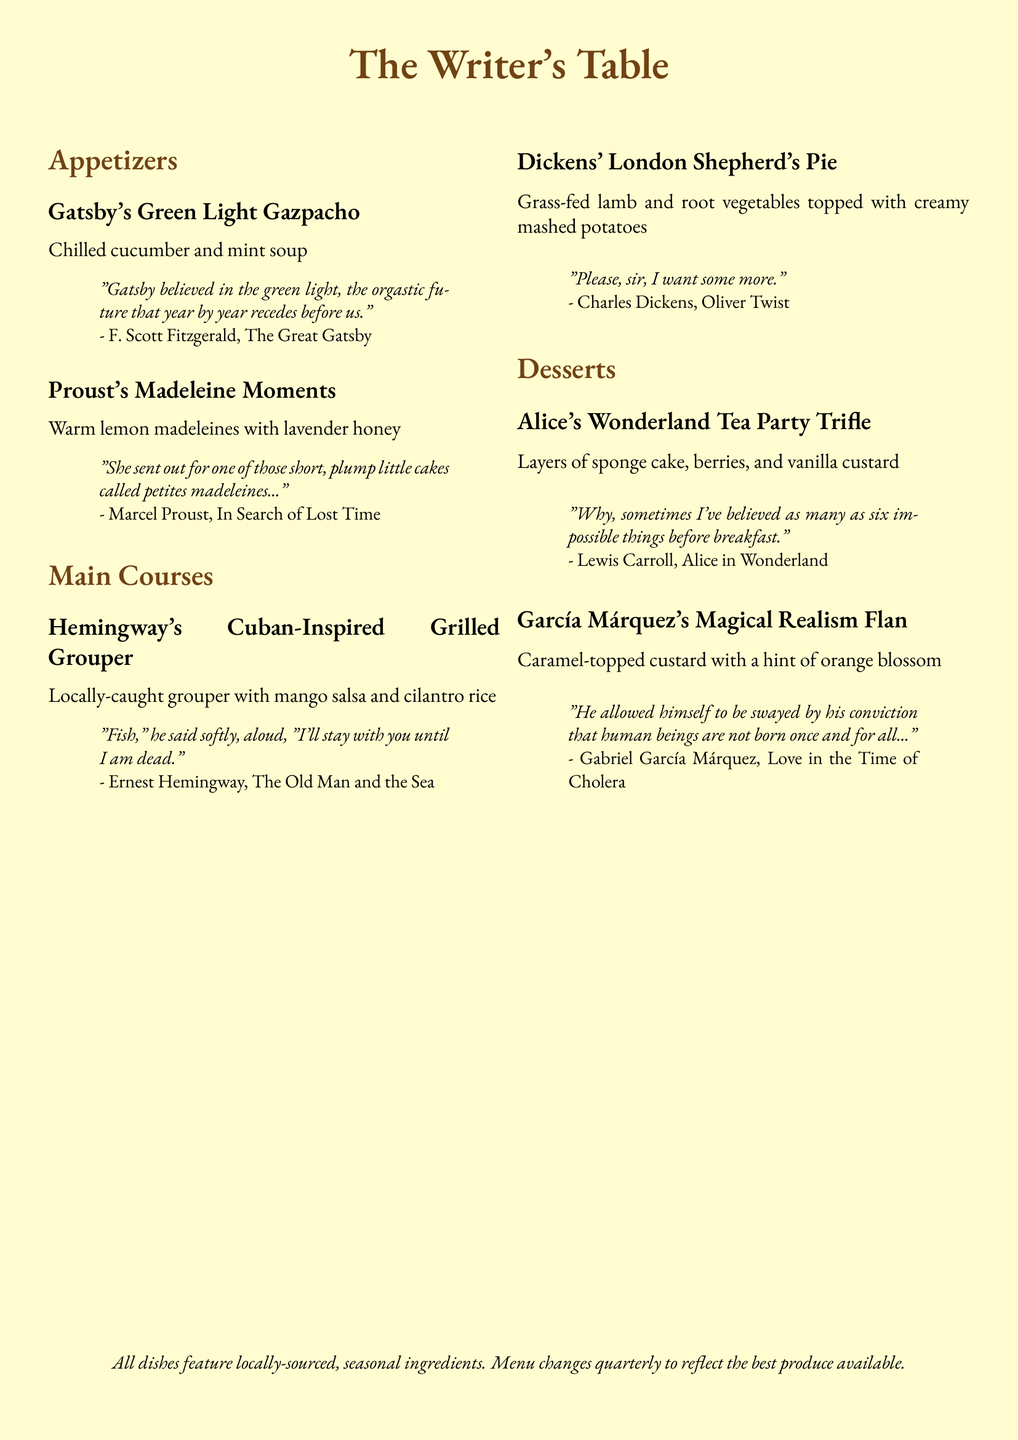What is the name of the appetizer inspired by F. Scott Fitzgerald? The appetizer inspired by F. Scott Fitzgerald is listed under the title "Gatsby's Green Light Gazpacho."
Answer: Gatsby's Green Light Gazpacho How many layers are in Alice's Wonderland Tea Party Trifle? The dessert description mentions layers of sponge cake, berries, and vanilla custard but does not specify the exact number of layers. However, it indicates there are multiple layers in the trifle.
Answer: Multiple layers What is the main ingredient in Hemingway's Cuban-Inspired Grilled Grouper? The main ingredient of this dish is locally-caught grouper as stated in the menu description.
Answer: Grouper Which literary figure is associated with the dessert featuring caramel-topped custard? The dessert featuring caramel-topped custard is associated with Gabriel García Márquez as mentioned in the menu description.
Answer: Gabriel García Márquez What type of soup is Gatsby's Green Light Gazpacho? The menu describes Gatsby's Green Light Gazpacho as a chilled cucumber and mint soup.
Answer: Chilled cucumber and mint soup What is the seasonality characteristic of the dishes featured in the menu? The menu indicates that all dishes feature locally-sourced, seasonal ingredients and changes quarterly.
Answer: Seasonal ingredients Which dish contains grass-fed lamb? The dish that contains grass-fed lamb is Dickens' London Shepherd's Pie, as specified in the description.
Answer: Dickens' London Shepherd's Pie What is the flavor hint in García Márquez's Magical Realism Flan? The flavor hint in this dessert is orange blossom, as mentioned in the description of the flan.
Answer: Orange blossom Who is the character associated with the phrase about believing in six impossible things? The character associated with this phrase is from Lewis Carroll's work, specifically relating to Alice from "Alice in Wonderland."
Answer: Alice 